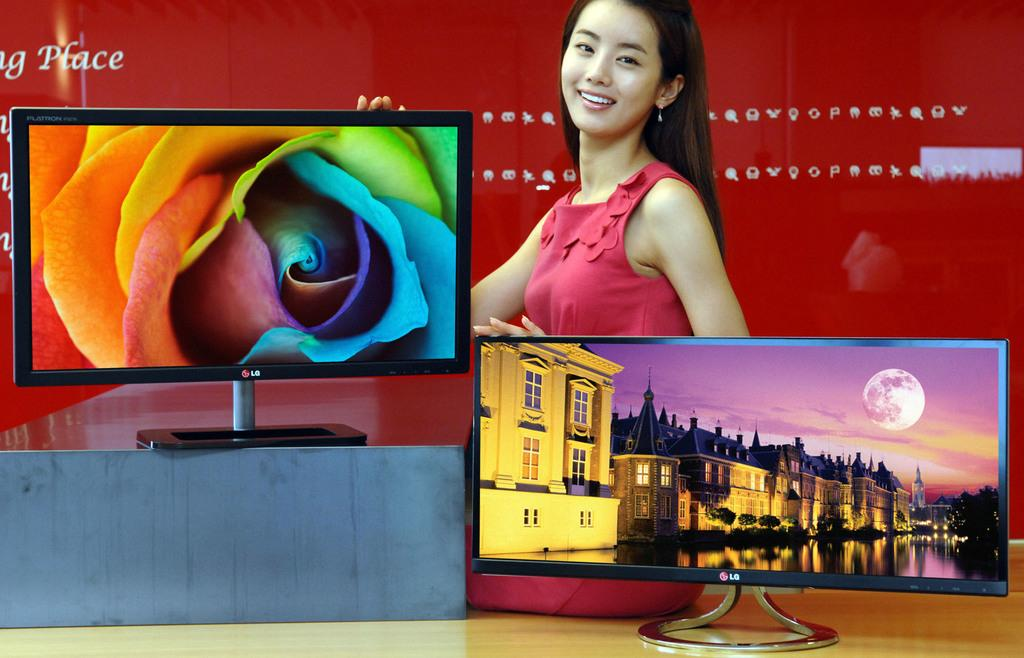<image>
Relay a brief, clear account of the picture shown. a television with a red background that says place 